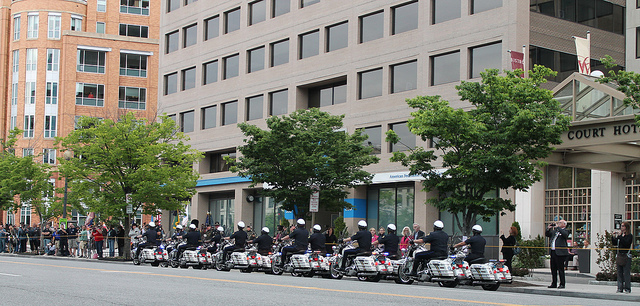Please identify all text content in this image. COURT HOT 